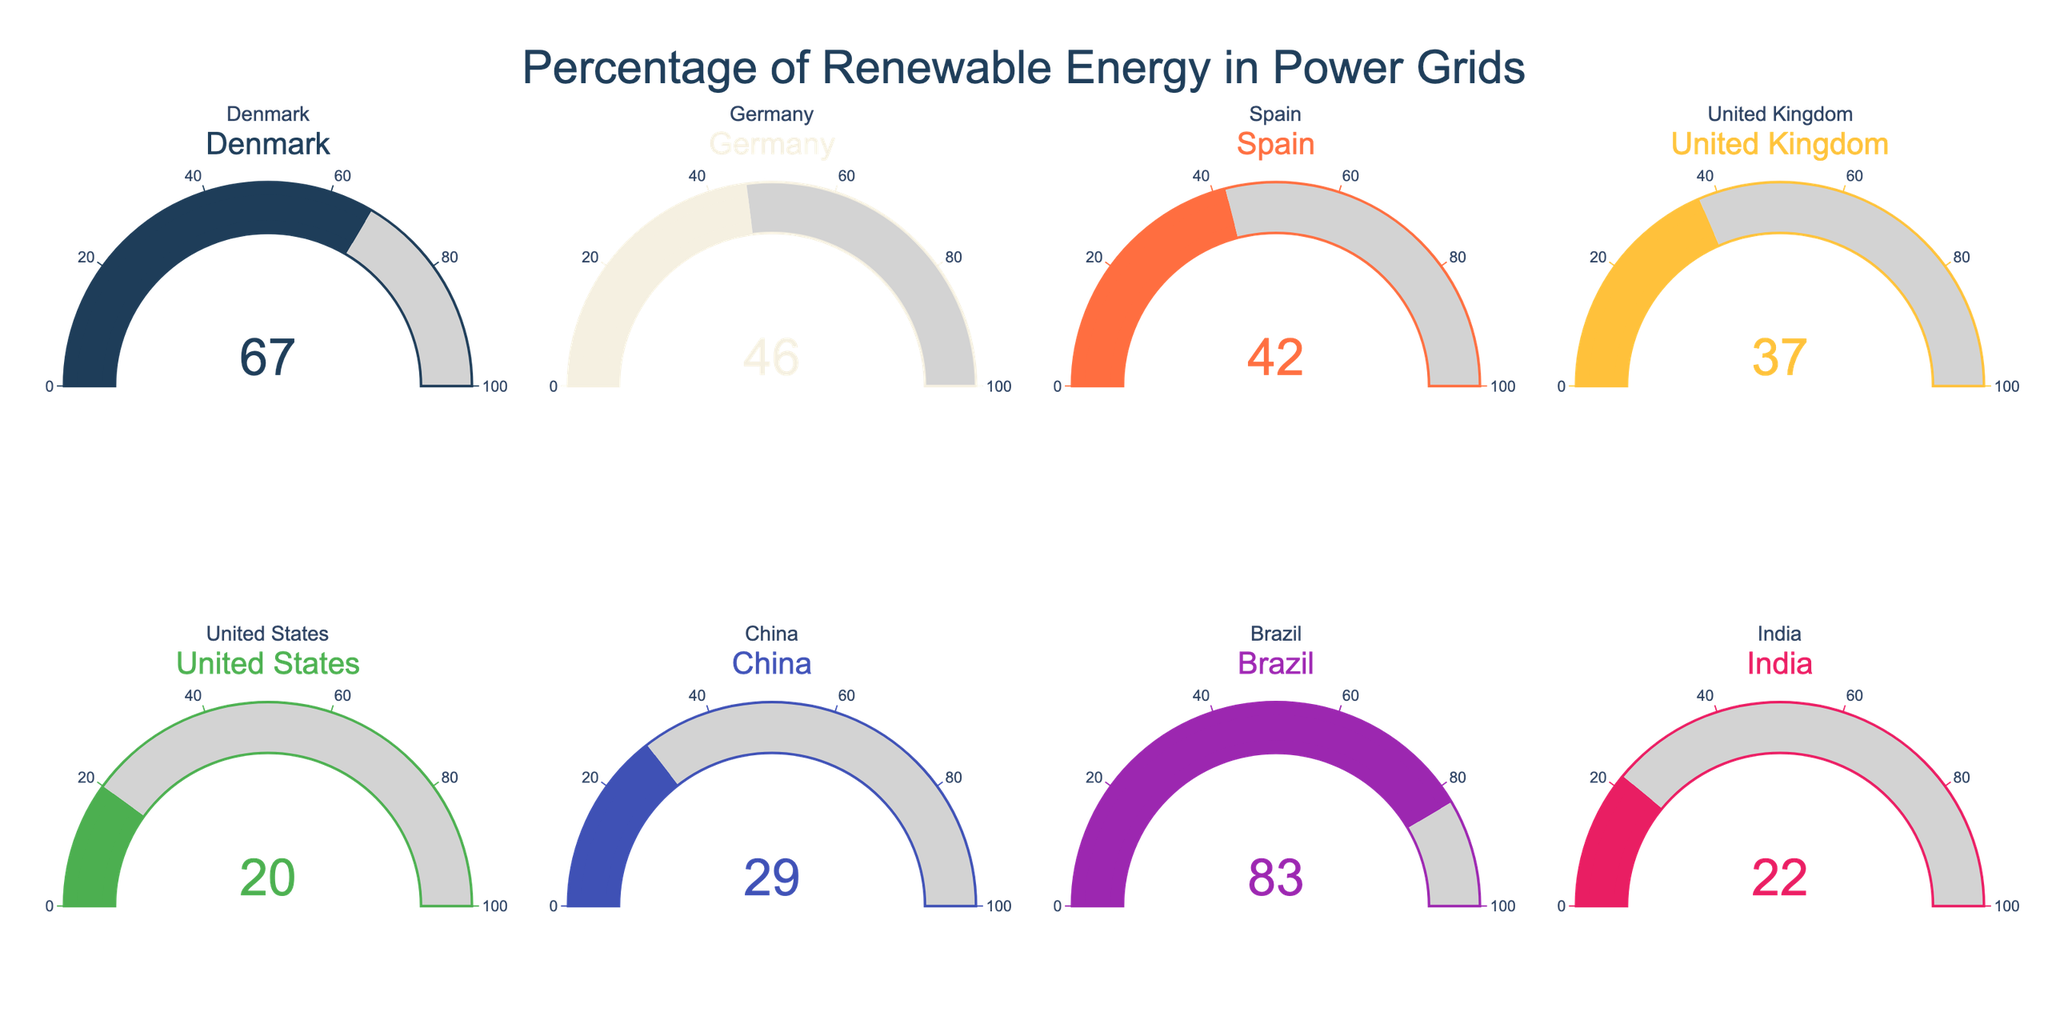what is the percentage of renewable energy in Denmark's power grid? From the gauge chart for Denmark, the needle points at 67, indicating the percentage of renewable energy.
Answer: 67 what is the lowest percentage of renewable energy among the countries shown? Among all the gauges, the United States' gauge shows the lowest value, which is 20.
Answer: 20 which country has the highest percentage of renewable energy? The gauge chart for Brazil shows the highest value, which is 83.
Answer: Brazil how much more renewable energy does Spain have compared to the United States? Spain's gauge shows 42, and the United States' gauge shows 20. The difference is 42 - 20 = 22.
Answer: 22 what is the average percentage of renewable energy in the power grids of Denmark, Germany, and Spain? The values for these countries are Denmark: 67, Germany: 46, and Spain: 42. The average is calculated as (67 + 46 + 42) / 3 = 155 / 3 ≈ 51.67.
Answer: 51.67 how does Brazil's renewable energy percentage compare to India's? Brazil's gauge shows 83, while India's shows 22. Brazil's renewable percentage is significantly higher.
Answer: Brazil's is higher which two countries have the closest renewable energy percentages? The renewable energy percentages for Germany and Spain are 46 and 42, respectively. The difference is only 4, which is less than any other pair.
Answer: Germany and Spain What is the total renewable energy percentage of China and India combined? China's gauge shows 29, and India's gauge shows 22. Their combined total is 29 + 22 = 51.
Answer: 51 what percentage of renewable energy is represented by the gauge colored with shades of green? The gauges for Denmark and Germany use shades of green. Denmark has 67% and Germany has 46%.
Answer: 67 and 46 Among the countries with renewable energy percentages above 40, what is their average renewable energy percentage? The countries above 40% are Denmark (67), Germany (46), Spain (42), and Brazil (83). Their average is (67 + 46 + 42 + 83) / 4 = 238 / 4 = 59.5.
Answer: 59.5 